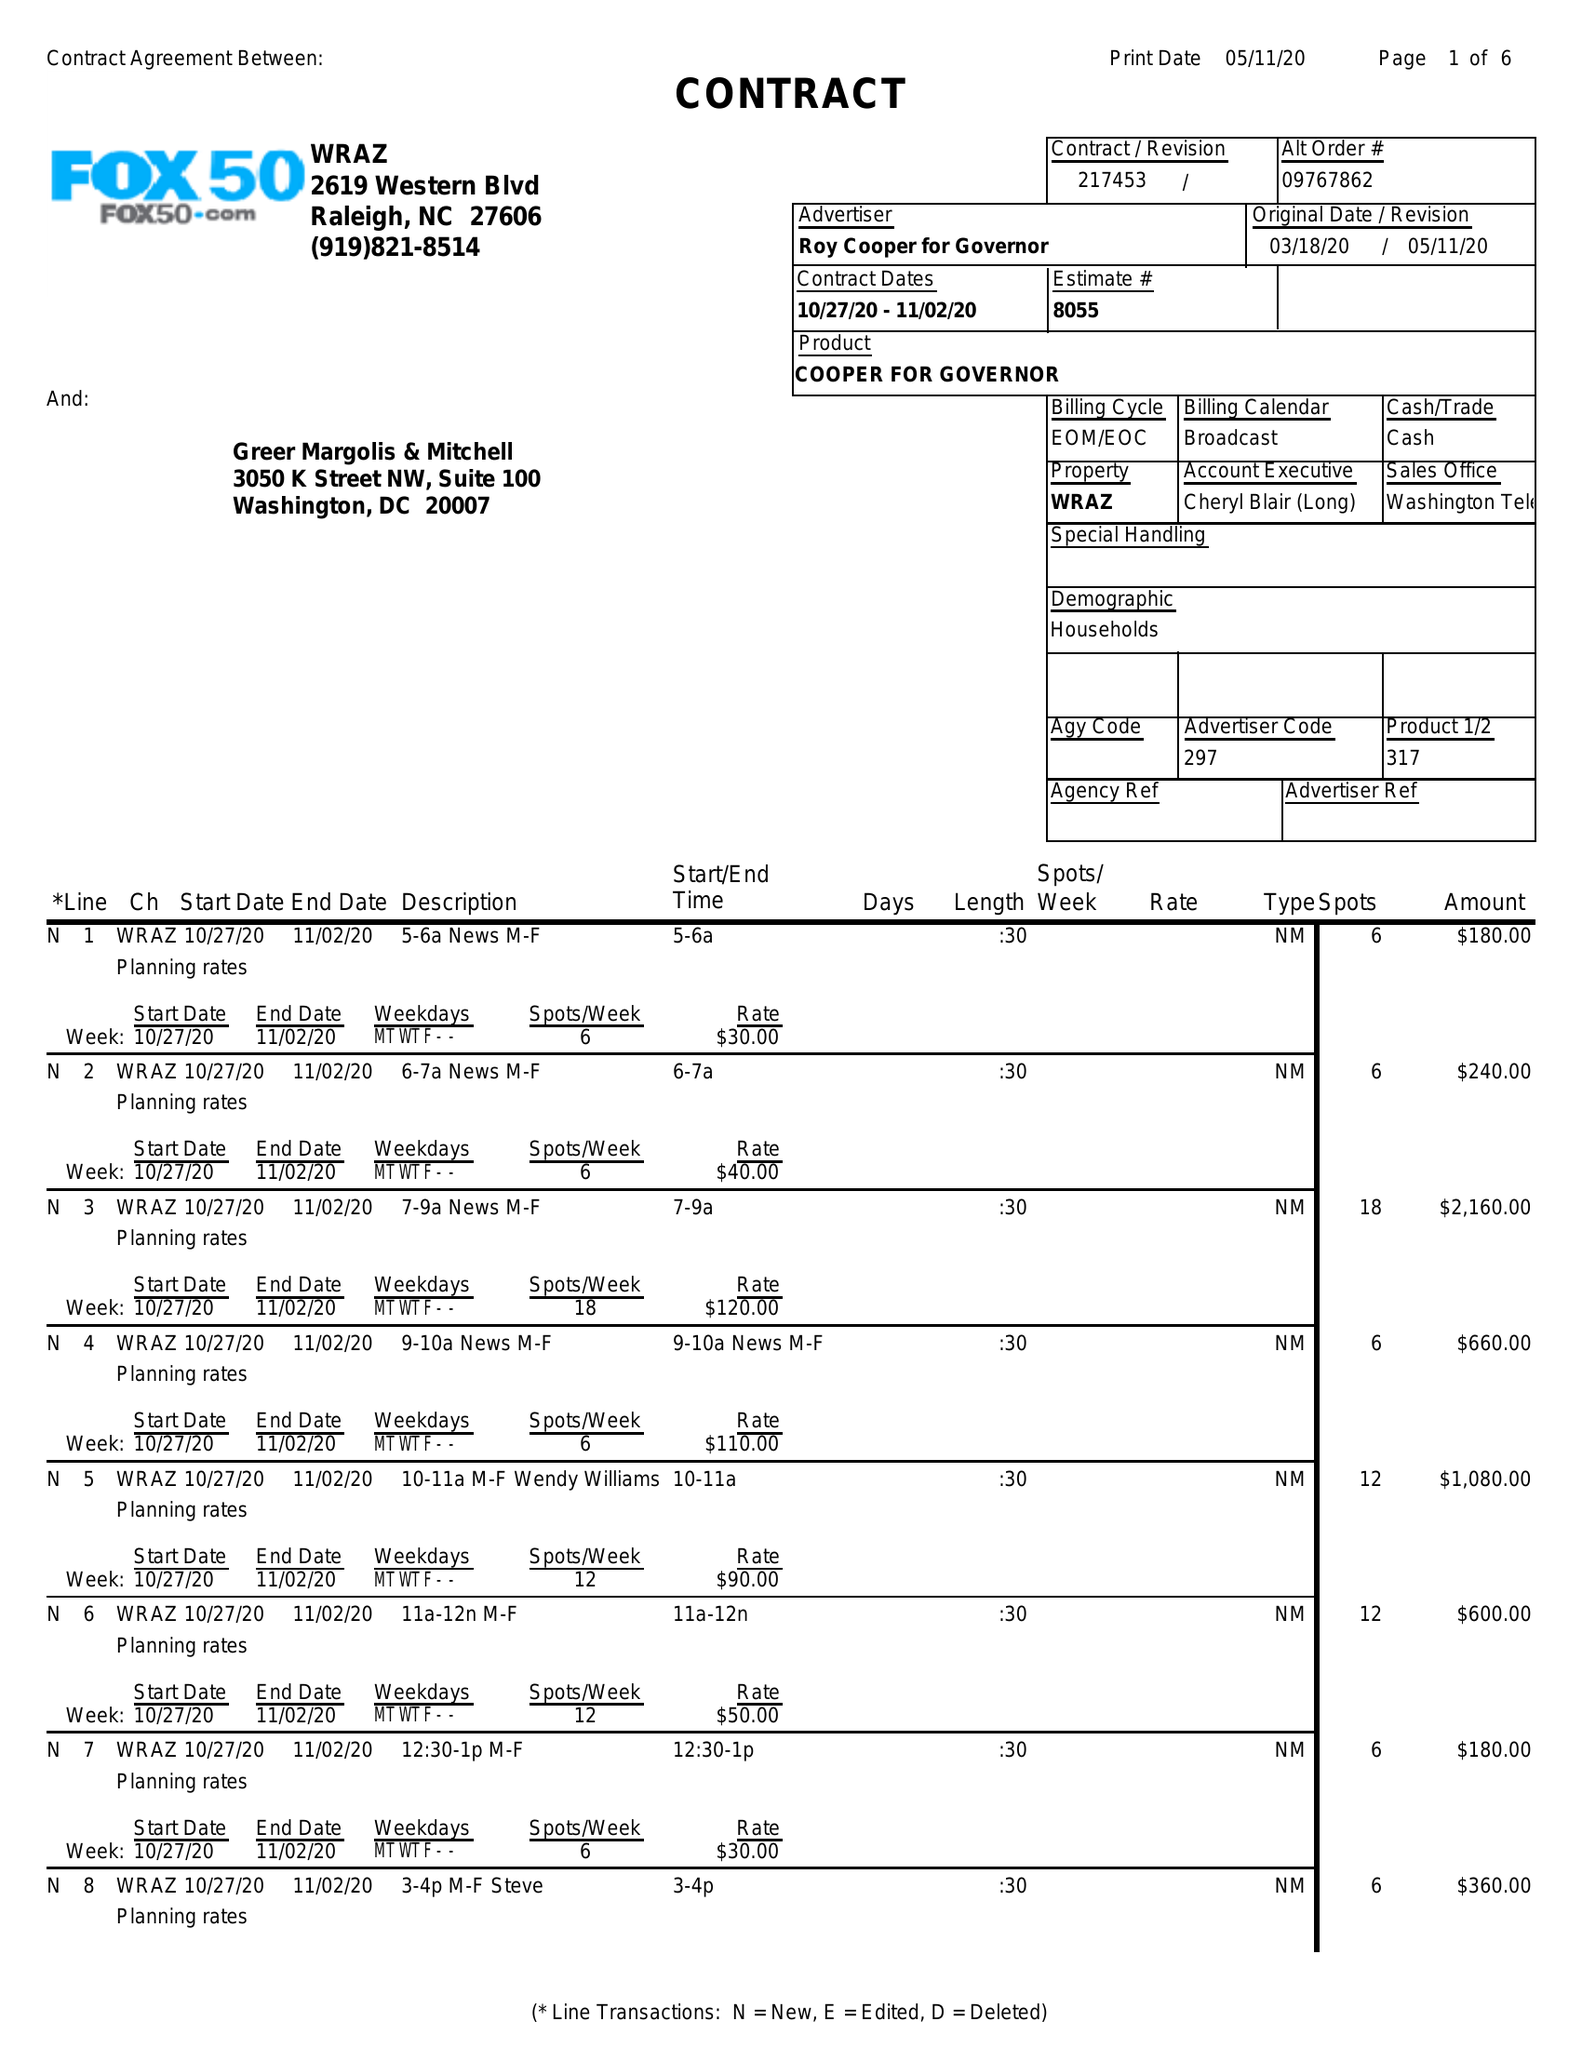What is the value for the contract_num?
Answer the question using a single word or phrase. 217453 